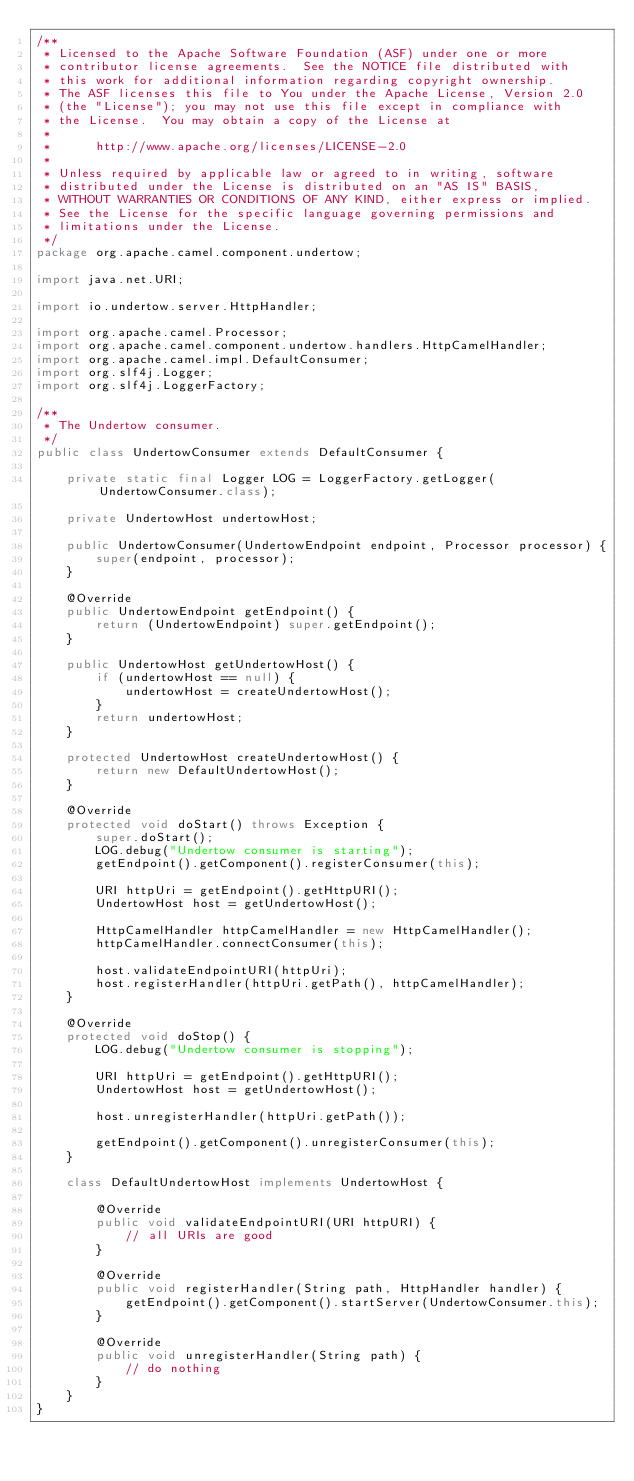<code> <loc_0><loc_0><loc_500><loc_500><_Java_>/**
 * Licensed to the Apache Software Foundation (ASF) under one or more
 * contributor license agreements.  See the NOTICE file distributed with
 * this work for additional information regarding copyright ownership.
 * The ASF licenses this file to You under the Apache License, Version 2.0
 * (the "License"); you may not use this file except in compliance with
 * the License.  You may obtain a copy of the License at
 *
 *      http://www.apache.org/licenses/LICENSE-2.0
 *
 * Unless required by applicable law or agreed to in writing, software
 * distributed under the License is distributed on an "AS IS" BASIS,
 * WITHOUT WARRANTIES OR CONDITIONS OF ANY KIND, either express or implied.
 * See the License for the specific language governing permissions and
 * limitations under the License.
 */
package org.apache.camel.component.undertow;

import java.net.URI;

import io.undertow.server.HttpHandler;

import org.apache.camel.Processor;
import org.apache.camel.component.undertow.handlers.HttpCamelHandler;
import org.apache.camel.impl.DefaultConsumer;
import org.slf4j.Logger;
import org.slf4j.LoggerFactory;

/**
 * The Undertow consumer.
 */
public class UndertowConsumer extends DefaultConsumer {

    private static final Logger LOG = LoggerFactory.getLogger(UndertowConsumer.class);

    private UndertowHost undertowHost;

    public UndertowConsumer(UndertowEndpoint endpoint, Processor processor) {
        super(endpoint, processor);
    }

    @Override
    public UndertowEndpoint getEndpoint() {
        return (UndertowEndpoint) super.getEndpoint();
    }

    public UndertowHost getUndertowHost() {
        if (undertowHost == null) {
            undertowHost = createUndertowHost();
        }
        return undertowHost;
    }

    protected UndertowHost createUndertowHost() {
        return new DefaultUndertowHost();
    }

    @Override
    protected void doStart() throws Exception {
        super.doStart();
        LOG.debug("Undertow consumer is starting");
        getEndpoint().getComponent().registerConsumer(this);

        URI httpUri = getEndpoint().getHttpURI();
        UndertowHost host = getUndertowHost();

        HttpCamelHandler httpCamelHandler = new HttpCamelHandler();
        httpCamelHandler.connectConsumer(this);

        host.validateEndpointURI(httpUri);
        host.registerHandler(httpUri.getPath(), httpCamelHandler);
    }

    @Override
    protected void doStop() {
        LOG.debug("Undertow consumer is stopping");

        URI httpUri = getEndpoint().getHttpURI();
        UndertowHost host = getUndertowHost();

        host.unregisterHandler(httpUri.getPath());

        getEndpoint().getComponent().unregisterConsumer(this);
    }

    class DefaultUndertowHost implements UndertowHost {

        @Override
        public void validateEndpointURI(URI httpURI) {
            // all URIs are good
        }

        @Override
        public void registerHandler(String path, HttpHandler handler) {
            getEndpoint().getComponent().startServer(UndertowConsumer.this);
        }

        @Override
        public void unregisterHandler(String path) {
            // do nothing
        }
    }
}
</code> 